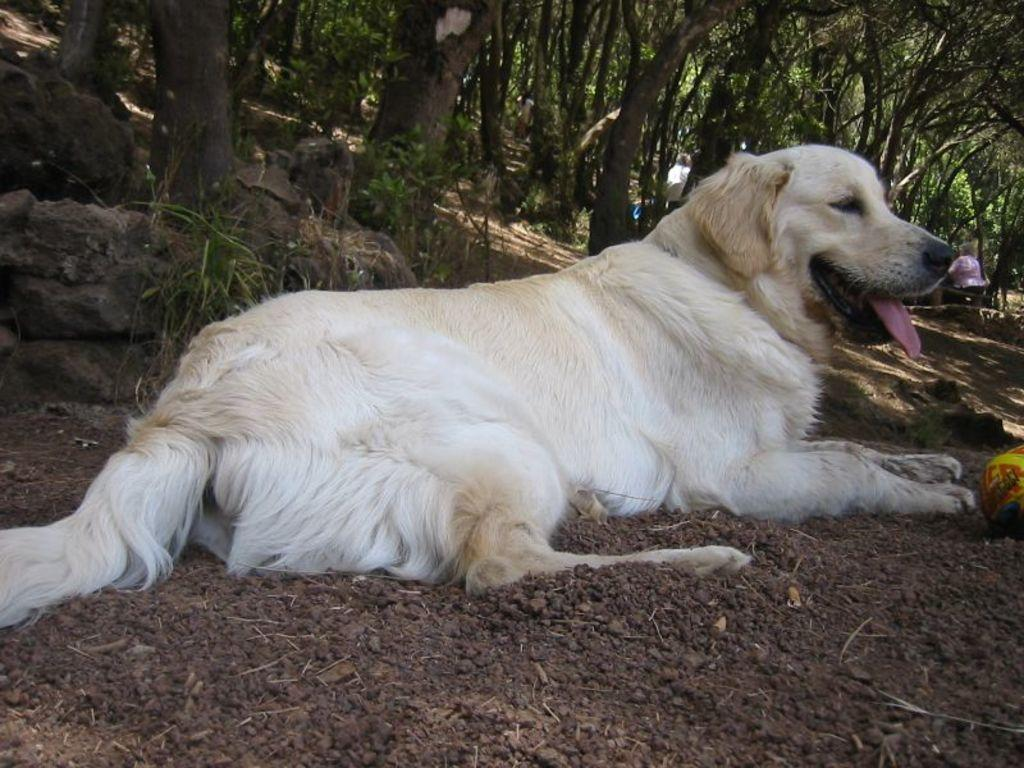What type of animal is in the image? There is a dog in the image. What colors can be seen on the dog? The dog is white, brown, and black in color. What position is the dog in? The dog is lying on the ground. What can be seen in the distance in the image? There are trees and other objects visible in the background of the image. What type of spy equipment can be seen in the image? There is no spy equipment present in the image; it features a dog lying on the ground. What type of leather item is visible in the image? There is no leather item present in the image. 